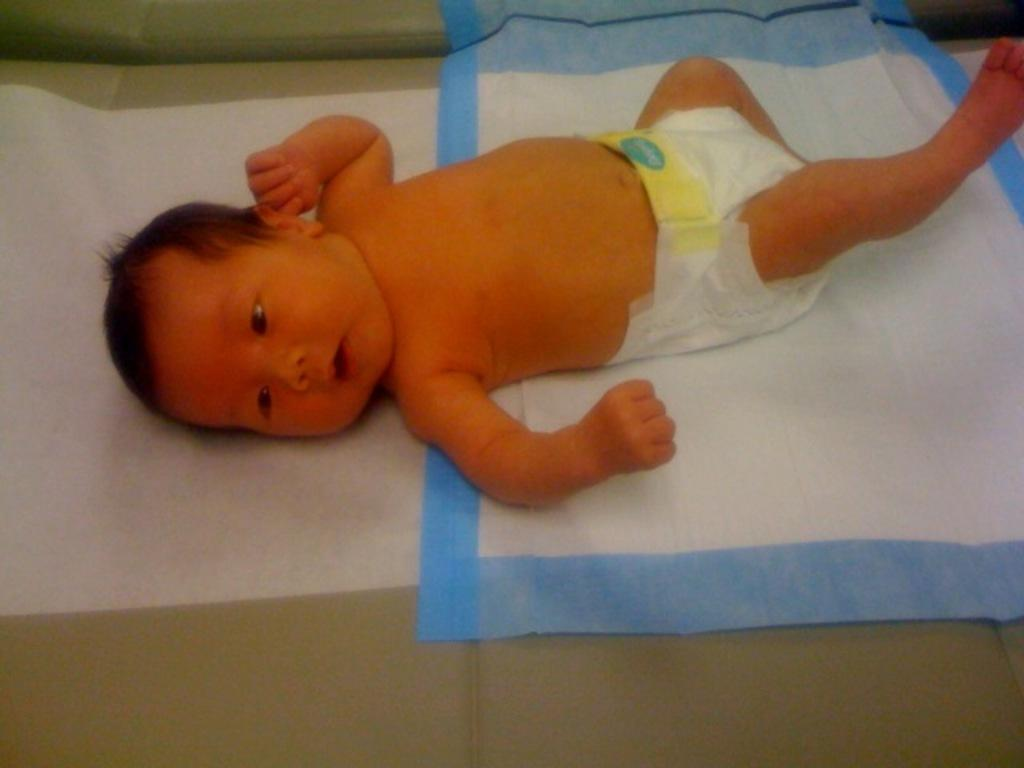What is the main subject of the image? There is a baby in the image. What else can be seen in the image besides the baby? There are clothes in the image. What type of business is being conducted in the image? There is no indication of any business being conducted in the image; it primarily features a baby and clothes. 